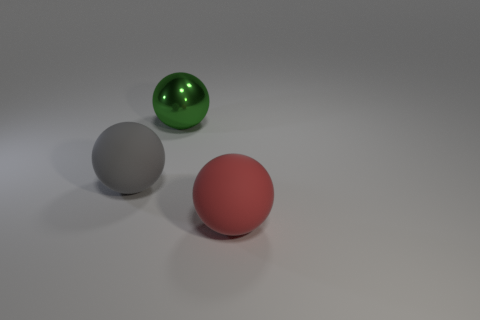There is a big matte sphere on the left side of the object that is in front of the big gray ball; are there any big objects that are on the right side of it?
Provide a short and direct response. Yes. Are there any large things that have the same color as the big metallic ball?
Your answer should be very brief. No. Do the large red thing and the big green shiny thing have the same shape?
Give a very brief answer. Yes. How many large things are either green balls or red matte balls?
Make the answer very short. 2. What is the color of the other large sphere that is made of the same material as the big gray sphere?
Offer a terse response. Red. How many red things are made of the same material as the red sphere?
Provide a succinct answer. 0. There is a ball in front of the gray rubber sphere; does it have the same size as the thing that is behind the large gray ball?
Ensure brevity in your answer.  Yes. There is a ball in front of the object that is to the left of the big green sphere; what is it made of?
Provide a succinct answer. Rubber. Are there fewer big gray matte spheres in front of the large red matte thing than gray things in front of the large gray matte thing?
Make the answer very short. No. Is there any other thing that is the same shape as the green thing?
Make the answer very short. Yes. 